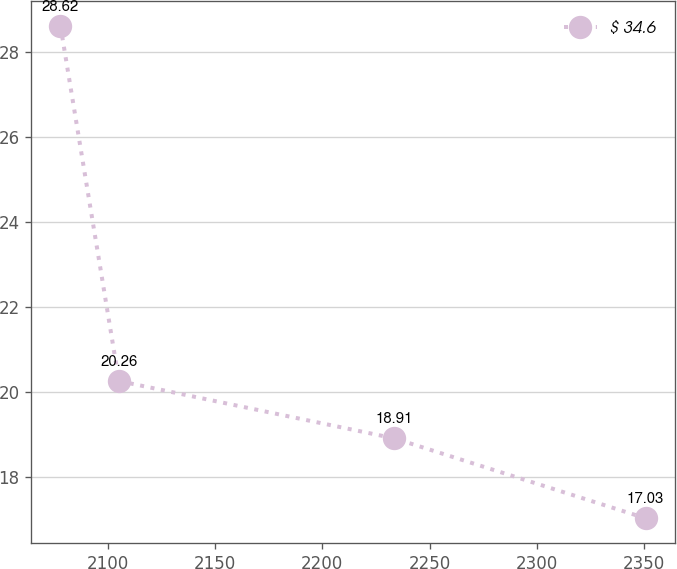Convert chart. <chart><loc_0><loc_0><loc_500><loc_500><line_chart><ecel><fcel>$ 34.6<nl><fcel>2077.87<fcel>28.62<nl><fcel>2105.16<fcel>20.26<nl><fcel>2233.63<fcel>18.91<nl><fcel>2350.82<fcel>17.03<nl></chart> 